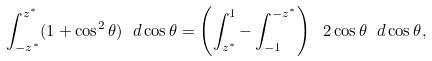Convert formula to latex. <formula><loc_0><loc_0><loc_500><loc_500>\int _ { - z ^ { * } } ^ { z ^ { * } } ( 1 + \cos ^ { 2 } \theta ) \ d \cos \theta = \left ( \int _ { z ^ { * } } ^ { 1 } - \int _ { - 1 } ^ { - z ^ { * } } \right ) \ 2 \cos \theta \ d \cos \theta ,</formula> 